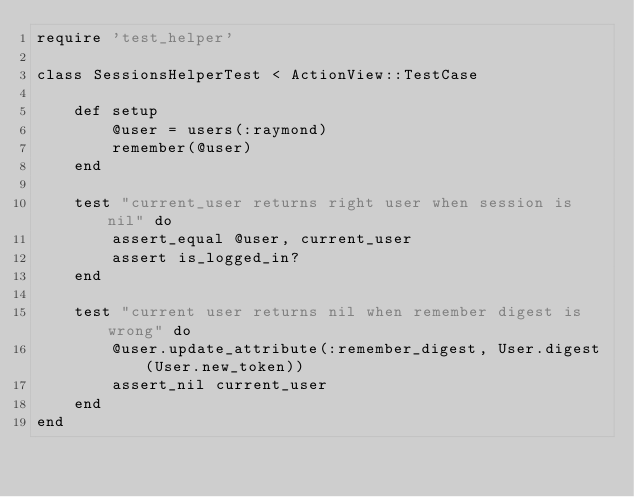<code> <loc_0><loc_0><loc_500><loc_500><_Ruby_>require 'test_helper'

class SessionsHelperTest < ActionView::TestCase

    def setup
        @user = users(:raymond)
        remember(@user)
    end

    test "current_user returns right user when session is nil" do
        assert_equal @user, current_user
        assert is_logged_in?
    end

    test "current user returns nil when remember digest is wrong" do
        @user.update_attribute(:remember_digest, User.digest(User.new_token))
        assert_nil current_user
    end
end
</code> 